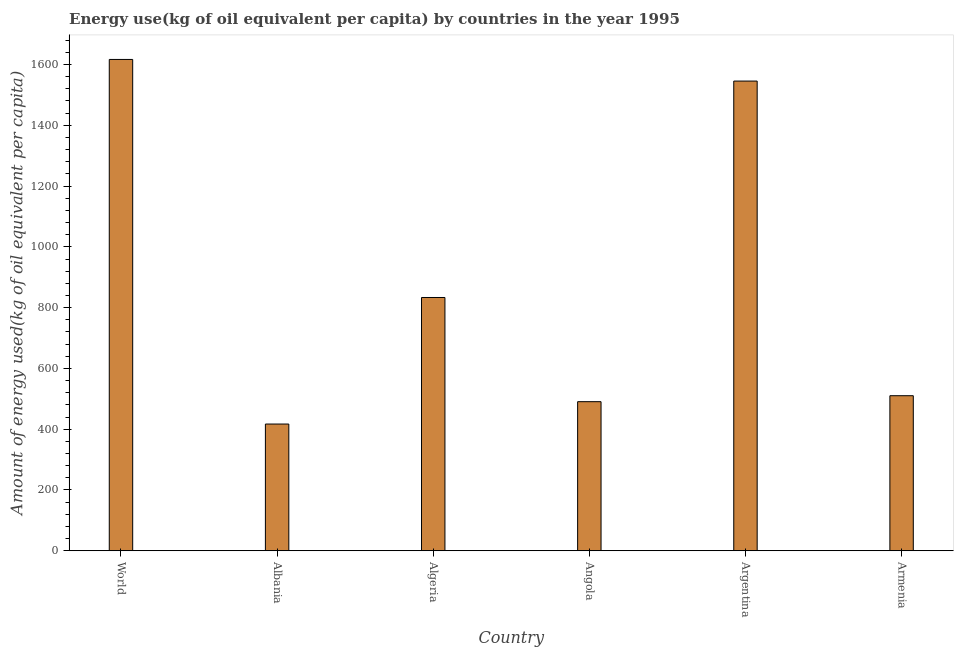What is the title of the graph?
Provide a short and direct response. Energy use(kg of oil equivalent per capita) by countries in the year 1995. What is the label or title of the Y-axis?
Offer a very short reply. Amount of energy used(kg of oil equivalent per capita). What is the amount of energy used in World?
Provide a short and direct response. 1616.71. Across all countries, what is the maximum amount of energy used?
Keep it short and to the point. 1616.71. Across all countries, what is the minimum amount of energy used?
Make the answer very short. 417.03. In which country was the amount of energy used minimum?
Offer a terse response. Albania. What is the sum of the amount of energy used?
Offer a very short reply. 5413.57. What is the difference between the amount of energy used in Albania and Angola?
Provide a short and direct response. -73.58. What is the average amount of energy used per country?
Your response must be concise. 902.26. What is the median amount of energy used?
Offer a very short reply. 671.83. In how many countries, is the amount of energy used greater than 160 kg?
Give a very brief answer. 6. What is the ratio of the amount of energy used in Albania to that in Armenia?
Provide a succinct answer. 0.82. What is the difference between the highest and the second highest amount of energy used?
Ensure brevity in your answer.  71.16. What is the difference between the highest and the lowest amount of energy used?
Give a very brief answer. 1199.67. How many countries are there in the graph?
Your response must be concise. 6. What is the Amount of energy used(kg of oil equivalent per capita) of World?
Your response must be concise. 1616.71. What is the Amount of energy used(kg of oil equivalent per capita) in Albania?
Provide a short and direct response. 417.03. What is the Amount of energy used(kg of oil equivalent per capita) in Algeria?
Your response must be concise. 833.41. What is the Amount of energy used(kg of oil equivalent per capita) in Angola?
Give a very brief answer. 490.61. What is the Amount of energy used(kg of oil equivalent per capita) in Argentina?
Give a very brief answer. 1545.55. What is the Amount of energy used(kg of oil equivalent per capita) in Armenia?
Make the answer very short. 510.25. What is the difference between the Amount of energy used(kg of oil equivalent per capita) in World and Albania?
Make the answer very short. 1199.67. What is the difference between the Amount of energy used(kg of oil equivalent per capita) in World and Algeria?
Provide a succinct answer. 783.3. What is the difference between the Amount of energy used(kg of oil equivalent per capita) in World and Angola?
Provide a short and direct response. 1126.09. What is the difference between the Amount of energy used(kg of oil equivalent per capita) in World and Argentina?
Ensure brevity in your answer.  71.16. What is the difference between the Amount of energy used(kg of oil equivalent per capita) in World and Armenia?
Give a very brief answer. 1106.46. What is the difference between the Amount of energy used(kg of oil equivalent per capita) in Albania and Algeria?
Keep it short and to the point. -416.38. What is the difference between the Amount of energy used(kg of oil equivalent per capita) in Albania and Angola?
Offer a terse response. -73.58. What is the difference between the Amount of energy used(kg of oil equivalent per capita) in Albania and Argentina?
Provide a short and direct response. -1128.52. What is the difference between the Amount of energy used(kg of oil equivalent per capita) in Albania and Armenia?
Your answer should be compact. -93.21. What is the difference between the Amount of energy used(kg of oil equivalent per capita) in Algeria and Angola?
Your response must be concise. 342.8. What is the difference between the Amount of energy used(kg of oil equivalent per capita) in Algeria and Argentina?
Offer a terse response. -712.14. What is the difference between the Amount of energy used(kg of oil equivalent per capita) in Algeria and Armenia?
Ensure brevity in your answer.  323.16. What is the difference between the Amount of energy used(kg of oil equivalent per capita) in Angola and Argentina?
Your response must be concise. -1054.94. What is the difference between the Amount of energy used(kg of oil equivalent per capita) in Angola and Armenia?
Offer a terse response. -19.63. What is the difference between the Amount of energy used(kg of oil equivalent per capita) in Argentina and Armenia?
Your answer should be compact. 1035.3. What is the ratio of the Amount of energy used(kg of oil equivalent per capita) in World to that in Albania?
Offer a very short reply. 3.88. What is the ratio of the Amount of energy used(kg of oil equivalent per capita) in World to that in Algeria?
Keep it short and to the point. 1.94. What is the ratio of the Amount of energy used(kg of oil equivalent per capita) in World to that in Angola?
Offer a very short reply. 3.29. What is the ratio of the Amount of energy used(kg of oil equivalent per capita) in World to that in Argentina?
Provide a short and direct response. 1.05. What is the ratio of the Amount of energy used(kg of oil equivalent per capita) in World to that in Armenia?
Your response must be concise. 3.17. What is the ratio of the Amount of energy used(kg of oil equivalent per capita) in Albania to that in Algeria?
Your response must be concise. 0.5. What is the ratio of the Amount of energy used(kg of oil equivalent per capita) in Albania to that in Argentina?
Your answer should be compact. 0.27. What is the ratio of the Amount of energy used(kg of oil equivalent per capita) in Albania to that in Armenia?
Keep it short and to the point. 0.82. What is the ratio of the Amount of energy used(kg of oil equivalent per capita) in Algeria to that in Angola?
Give a very brief answer. 1.7. What is the ratio of the Amount of energy used(kg of oil equivalent per capita) in Algeria to that in Argentina?
Ensure brevity in your answer.  0.54. What is the ratio of the Amount of energy used(kg of oil equivalent per capita) in Algeria to that in Armenia?
Provide a succinct answer. 1.63. What is the ratio of the Amount of energy used(kg of oil equivalent per capita) in Angola to that in Argentina?
Your answer should be very brief. 0.32. What is the ratio of the Amount of energy used(kg of oil equivalent per capita) in Angola to that in Armenia?
Ensure brevity in your answer.  0.96. What is the ratio of the Amount of energy used(kg of oil equivalent per capita) in Argentina to that in Armenia?
Your response must be concise. 3.03. 